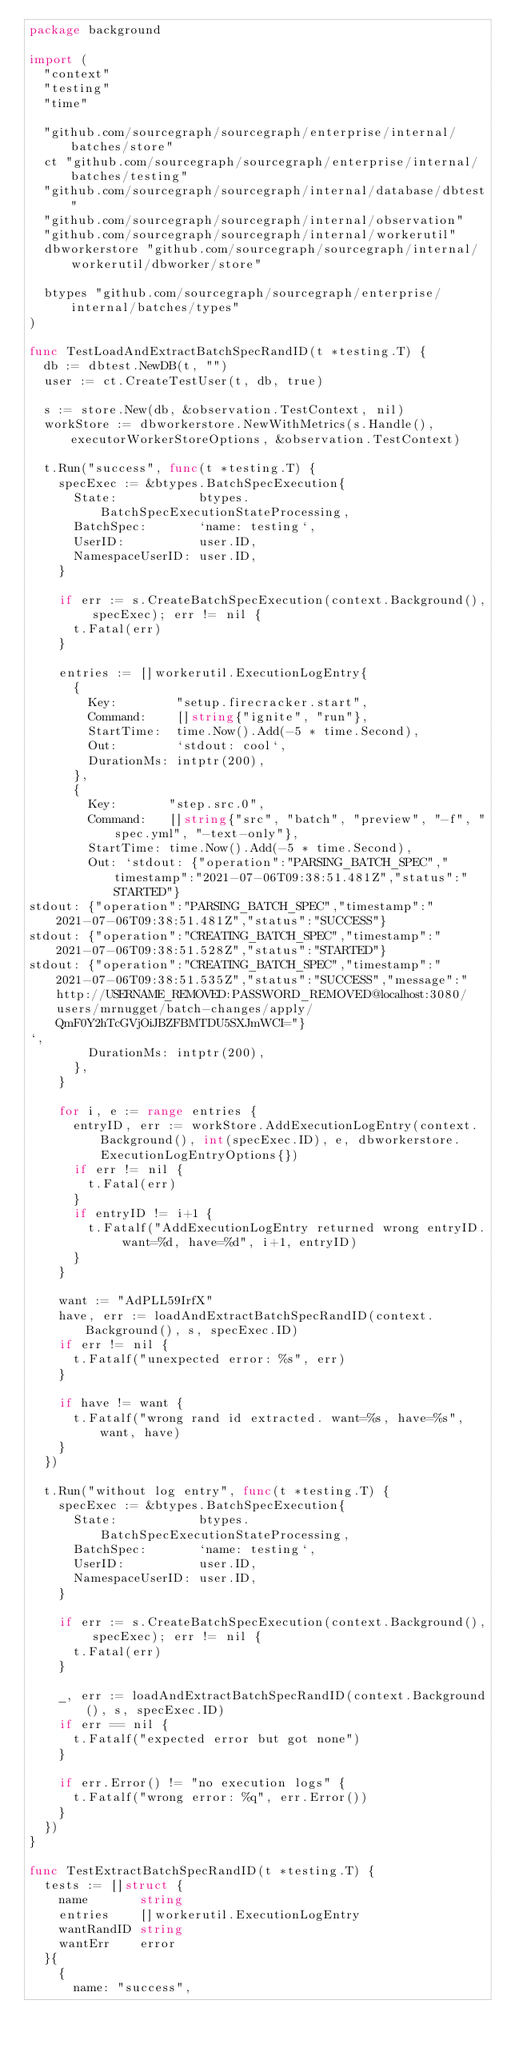<code> <loc_0><loc_0><loc_500><loc_500><_Go_>package background

import (
	"context"
	"testing"
	"time"

	"github.com/sourcegraph/sourcegraph/enterprise/internal/batches/store"
	ct "github.com/sourcegraph/sourcegraph/enterprise/internal/batches/testing"
	"github.com/sourcegraph/sourcegraph/internal/database/dbtest"
	"github.com/sourcegraph/sourcegraph/internal/observation"
	"github.com/sourcegraph/sourcegraph/internal/workerutil"
	dbworkerstore "github.com/sourcegraph/sourcegraph/internal/workerutil/dbworker/store"

	btypes "github.com/sourcegraph/sourcegraph/enterprise/internal/batches/types"
)

func TestLoadAndExtractBatchSpecRandID(t *testing.T) {
	db := dbtest.NewDB(t, "")
	user := ct.CreateTestUser(t, db, true)

	s := store.New(db, &observation.TestContext, nil)
	workStore := dbworkerstore.NewWithMetrics(s.Handle(), executorWorkerStoreOptions, &observation.TestContext)

	t.Run("success", func(t *testing.T) {
		specExec := &btypes.BatchSpecExecution{
			State:           btypes.BatchSpecExecutionStateProcessing,
			BatchSpec:       `name: testing`,
			UserID:          user.ID,
			NamespaceUserID: user.ID,
		}

		if err := s.CreateBatchSpecExecution(context.Background(), specExec); err != nil {
			t.Fatal(err)
		}

		entries := []workerutil.ExecutionLogEntry{
			{
				Key:        "setup.firecracker.start",
				Command:    []string{"ignite", "run"},
				StartTime:  time.Now().Add(-5 * time.Second),
				Out:        `stdout: cool`,
				DurationMs: intptr(200),
			},
			{
				Key:       "step.src.0",
				Command:   []string{"src", "batch", "preview", "-f", "spec.yml", "-text-only"},
				StartTime: time.Now().Add(-5 * time.Second),
				Out: `stdout: {"operation":"PARSING_BATCH_SPEC","timestamp":"2021-07-06T09:38:51.481Z","status":"STARTED"}
stdout: {"operation":"PARSING_BATCH_SPEC","timestamp":"2021-07-06T09:38:51.481Z","status":"SUCCESS"}
stdout: {"operation":"CREATING_BATCH_SPEC","timestamp":"2021-07-06T09:38:51.528Z","status":"STARTED"}
stdout: {"operation":"CREATING_BATCH_SPEC","timestamp":"2021-07-06T09:38:51.535Z","status":"SUCCESS","message":"http://USERNAME_REMOVED:PASSWORD_REMOVED@localhost:3080/users/mrnugget/batch-changes/apply/QmF0Y2hTcGVjOiJBZFBMTDU5SXJmWCI="}
`,
				DurationMs: intptr(200),
			},
		}

		for i, e := range entries {
			entryID, err := workStore.AddExecutionLogEntry(context.Background(), int(specExec.ID), e, dbworkerstore.ExecutionLogEntryOptions{})
			if err != nil {
				t.Fatal(err)
			}
			if entryID != i+1 {
				t.Fatalf("AddExecutionLogEntry returned wrong entryID. want=%d, have=%d", i+1, entryID)
			}
		}

		want := "AdPLL59IrfX"
		have, err := loadAndExtractBatchSpecRandID(context.Background(), s, specExec.ID)
		if err != nil {
			t.Fatalf("unexpected error: %s", err)
		}

		if have != want {
			t.Fatalf("wrong rand id extracted. want=%s, have=%s", want, have)
		}
	})

	t.Run("without log entry", func(t *testing.T) {
		specExec := &btypes.BatchSpecExecution{
			State:           btypes.BatchSpecExecutionStateProcessing,
			BatchSpec:       `name: testing`,
			UserID:          user.ID,
			NamespaceUserID: user.ID,
		}

		if err := s.CreateBatchSpecExecution(context.Background(), specExec); err != nil {
			t.Fatal(err)
		}

		_, err := loadAndExtractBatchSpecRandID(context.Background(), s, specExec.ID)
		if err == nil {
			t.Fatalf("expected error but got none")
		}

		if err.Error() != "no execution logs" {
			t.Fatalf("wrong error: %q", err.Error())
		}
	})
}

func TestExtractBatchSpecRandID(t *testing.T) {
	tests := []struct {
		name       string
		entries    []workerutil.ExecutionLogEntry
		wantRandID string
		wantErr    error
	}{
		{
			name: "success",</code> 